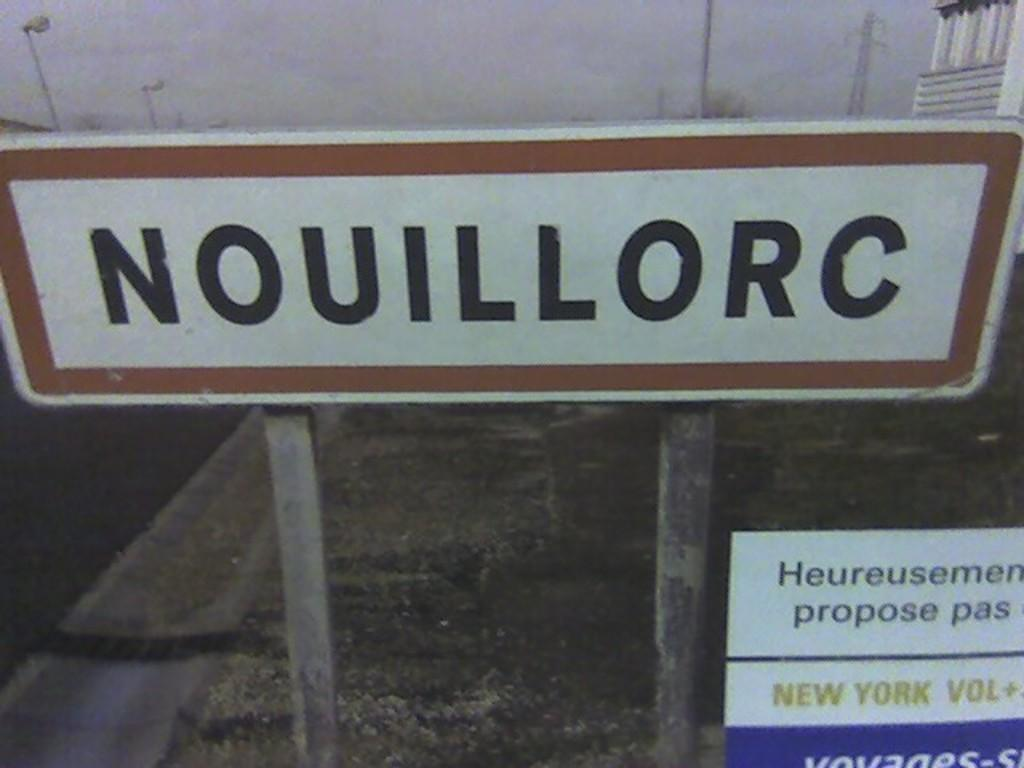<image>
Relay a brief, clear account of the picture shown. The sign in the photo has a mention of New York Vol. 